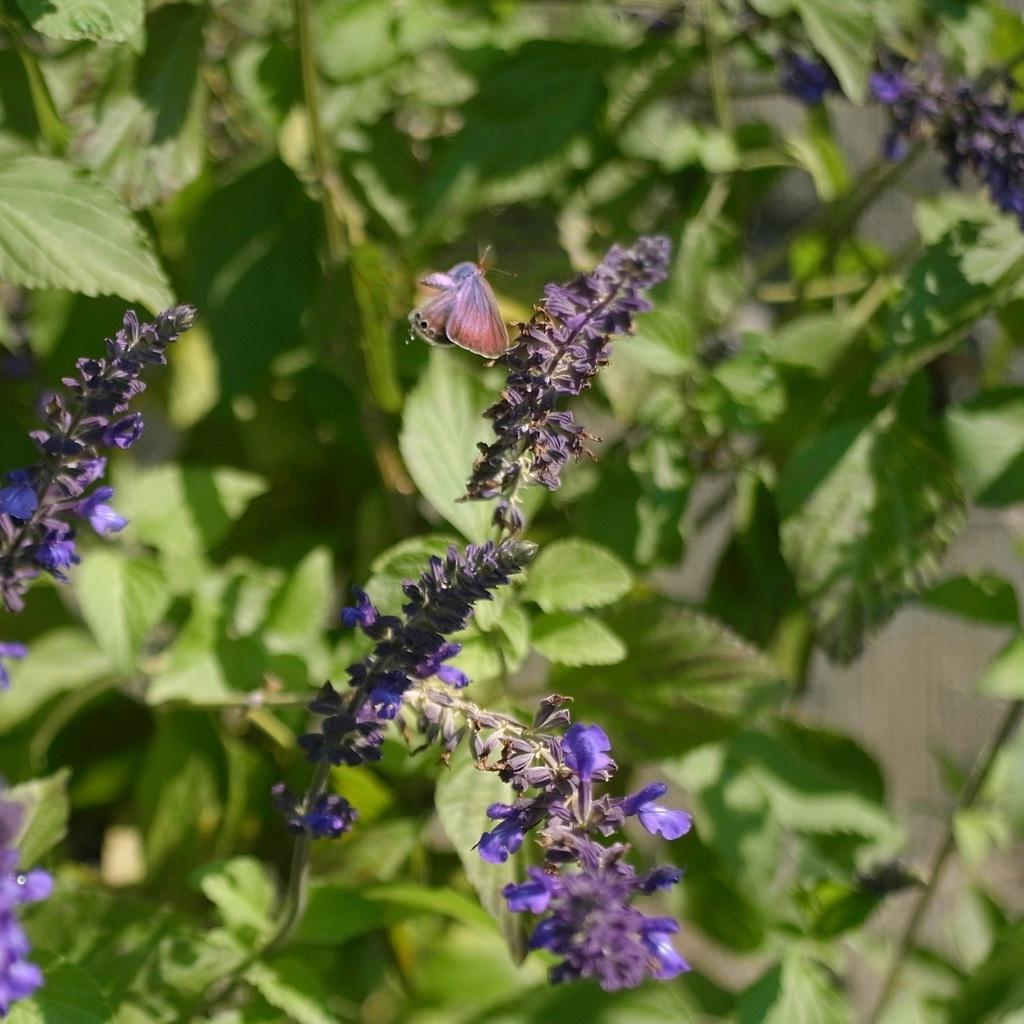What is located in the front portion of the image? There is a plant and an insect in the front portion of the image. Can you describe the insect in the image? The insect in the image is not specified, but it is present in the front portion. How would you describe the background of the image? The background portion of the image is blurry. What can be seen in the background of the image? Leaves are visible in the background portion of the image. How does the plant receive a haircut in the image? The plant does not receive a haircut in the image; it is a static image of a plant. What type of fork can be seen in the image? There is no fork present in the image. 